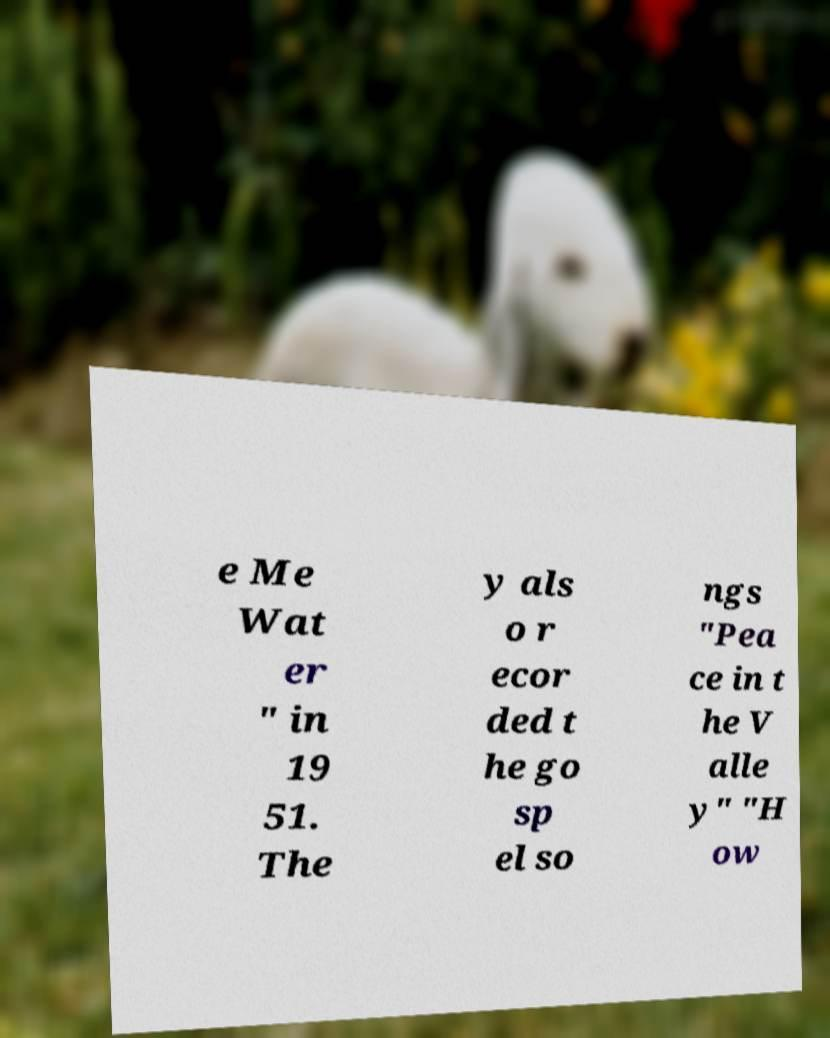Can you accurately transcribe the text from the provided image for me? e Me Wat er " in 19 51. The y als o r ecor ded t he go sp el so ngs "Pea ce in t he V alle y" "H ow 